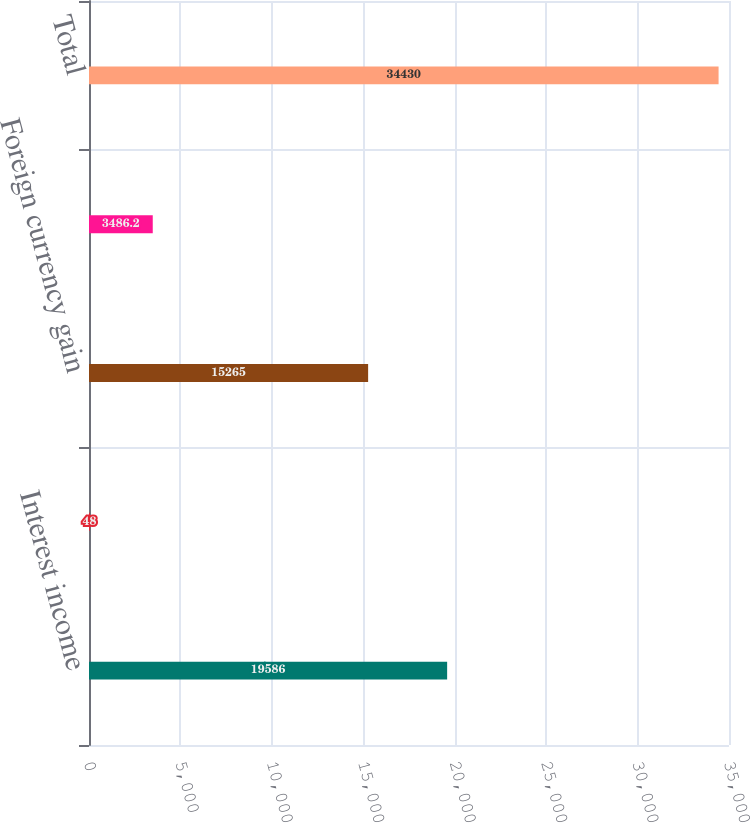Convert chart. <chart><loc_0><loc_0><loc_500><loc_500><bar_chart><fcel>Interest income<fcel>Interest expense<fcel>Foreign currency gain<fcel>Other<fcel>Total<nl><fcel>19586<fcel>48<fcel>15265<fcel>3486.2<fcel>34430<nl></chart> 